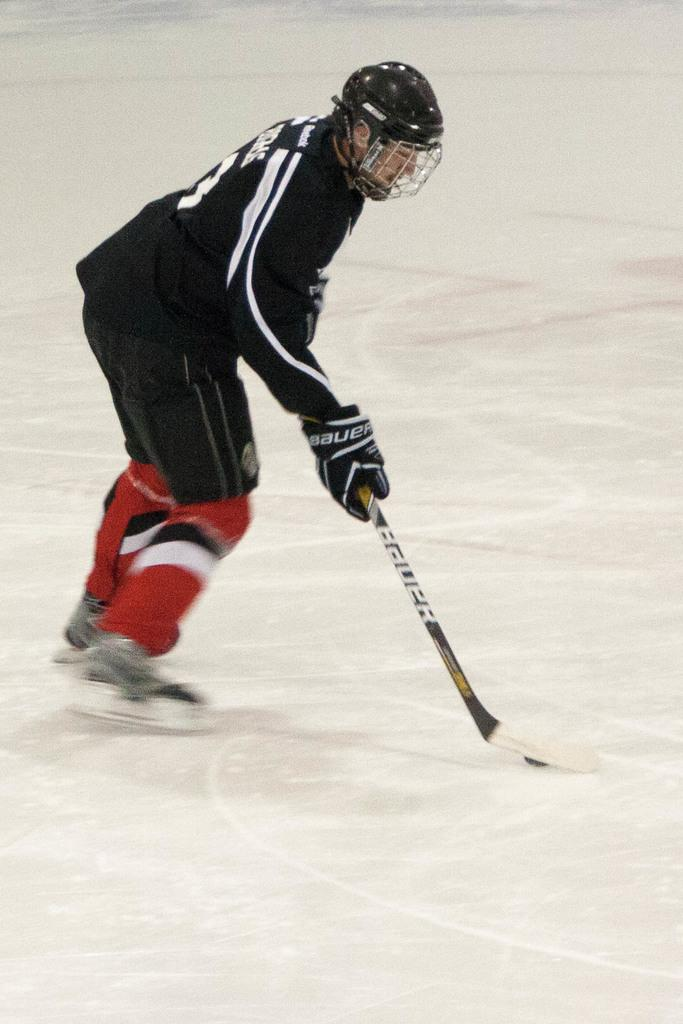Who is present in the image? There is a person in the image. What protective gear is the person wearing? The person is wearing a helmet and gloves. What object is the person holding? The person is holding a hockey stick. What activity is the person engaged in? The person is playing ice hockey. What type of pie is the person holding in the image? There is no pie present in the image; the person is holding a hockey stick. What type of quill is the person using to write on the ice? There is no quill or writing activity present in the image; the person is playing ice hockey. 